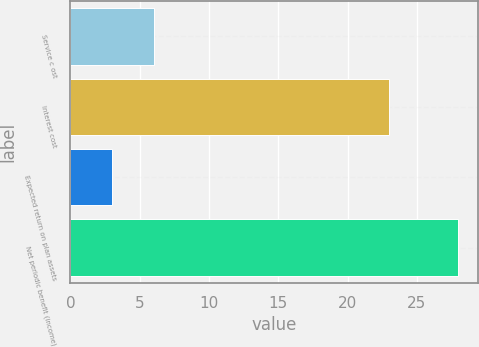<chart> <loc_0><loc_0><loc_500><loc_500><bar_chart><fcel>Service c ost<fcel>Interest cost<fcel>Expected return on plan assets<fcel>Net periodic benefit (income)<nl><fcel>6<fcel>23<fcel>3<fcel>28<nl></chart> 